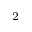Convert formula to latex. <formula><loc_0><loc_0><loc_500><loc_500>^ { 2 }</formula> 